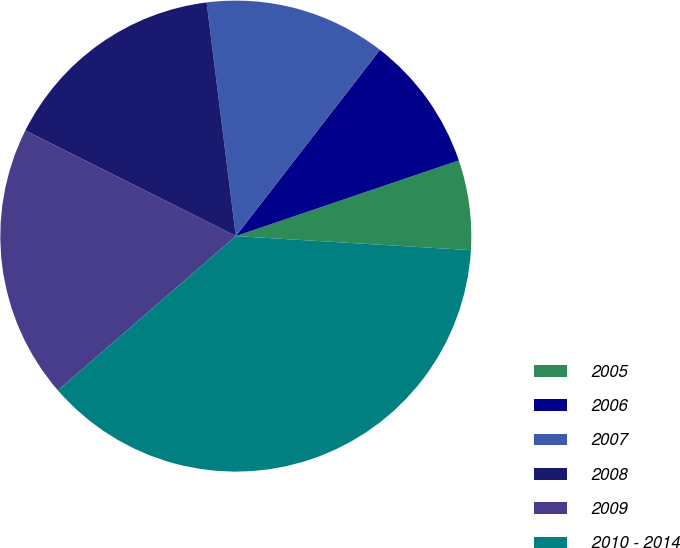Convert chart. <chart><loc_0><loc_0><loc_500><loc_500><pie_chart><fcel>2005<fcel>2006<fcel>2007<fcel>2008<fcel>2009<fcel>2010 - 2014<nl><fcel>6.16%<fcel>9.31%<fcel>12.46%<fcel>15.62%<fcel>18.77%<fcel>37.68%<nl></chart> 